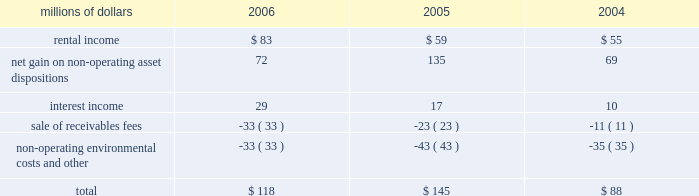The environmental liability includes costs for remediation and restoration of sites , as well as for ongoing monitoring costs , but excludes any anticipated recoveries from third parties .
Cost estimates are based on information available for each site , financial viability of other potentially responsible parties , and existing technology , laws , and regulations .
We believe that we have adequately accrued for our ultimate share of costs at sites subject to joint and several liability .
However , the ultimate liability for remediation is difficult to determine because of the number of potentially responsible parties involved , site-specific cost sharing arrangements with other potentially responsible parties , the degree of contamination by various wastes , the scarcity and quality of volumetric data related to many of the sites , and the speculative nature of remediation costs .
Estimates may also vary due to changes in federal , state , and local laws governing environmental remediation .
We do not expect current obligations to have a material adverse effect on our results of operations or financial condition .
Guarantees 2013 at december 31 , 2006 , we were contingently liable for $ 464 million in guarantees .
We have recorded a liability of $ 6 million for the fair value of these obligations as of december 31 , 2006 .
We entered into these contingent guarantees in the normal course of business , and they include guaranteed obligations related to our headquarters building , equipment financings , and affiliated operations .
The final guarantee expires in 2022 .
We are not aware of any existing event of default that would require us to satisfy these guarantees .
We do not expect that these guarantees will have a material adverse effect on our consolidated financial condition , results of operations , or liquidity .
Indemnities 2013 our maximum potential exposure under indemnification arrangements , including certain tax indemnifications , can range from a specified dollar amount to an unlimited amount , depending on the nature of the transactions and the agreements .
Due to uncertainty as to whether claims will be made or how they will be resolved , we cannot reasonably determine the probability of an adverse claim or reasonably estimate any adverse liability or the total maximum exposure under these indemnification arrangements .
We do not have any reason to believe that we will be required to make any material payments under these indemnity provisions .
Income taxes 2013 as previously reported in our form 10-q for the quarter ended september 30 , 2005 , the irs has completed its examinations and issued notices of deficiency for tax years 1995 through 2002 .
Among their proposed adjustments is the disallowance of tax deductions claimed in connection with certain donations of property .
In the fourth quarter of 2005 , the irs national office issued a technical advice memorandum which left unresolved whether the deductions were proper , pending further factual development .
We continue to dispute the donation issue , as well as many of the other proposed adjustments , and will contest the associated tax deficiencies through the irs appeals process , and , if necessary , litigation .
In addition , the irs is examining the corporation 2019s federal income tax returns for tax years 2003 and 2004 and should complete their exam in 2007 .
We do not expect that the ultimate resolution of these examinations will have a material adverse effect on our consolidated financial statements .
11 .
Other income other income included the following for the years ended december 31 : millions of dollars 2006 2005 2004 .

What was the percentage change in rental income from 2005 to 2006? 
Computations: ((83 - 59) / 59)
Answer: 0.40678. 